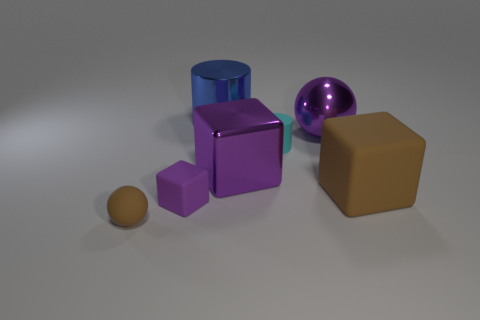Are there fewer big shiny cylinders that are on the left side of the blue object than yellow rubber objects?
Offer a terse response. No. Is the shape of the brown object on the right side of the blue metallic thing the same as the purple metallic thing right of the cyan rubber cylinder?
Your answer should be very brief. No. What number of things are objects that are behind the big sphere or large brown metal objects?
Keep it short and to the point. 1. What is the material of the sphere that is the same color as the big shiny block?
Offer a very short reply. Metal. There is a ball in front of the ball that is right of the big blue cylinder; is there a blue metallic thing to the left of it?
Offer a very short reply. No. Is the number of big purple spheres that are to the right of the big blue metal cylinder less than the number of small matte cylinders that are in front of the big rubber object?
Your answer should be very brief. No. What color is the big cube that is the same material as the big cylinder?
Offer a very short reply. Purple. The matte thing that is to the right of the tiny cyan cylinder behind the large brown cube is what color?
Your response must be concise. Brown. Is there a matte sphere of the same color as the metal ball?
Provide a short and direct response. No. What is the shape of the brown thing that is the same size as the purple ball?
Provide a succinct answer. Cube. 